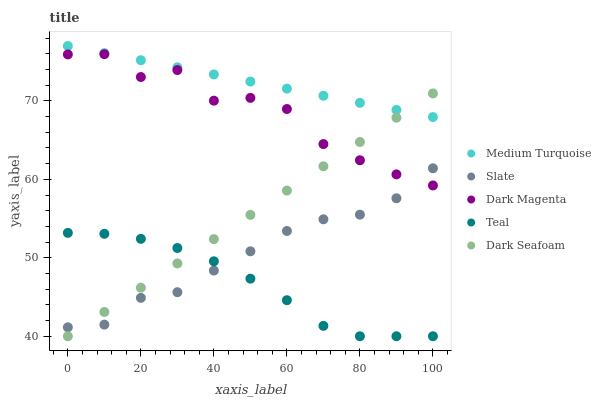Does Teal have the minimum area under the curve?
Answer yes or no. Yes. Does Medium Turquoise have the maximum area under the curve?
Answer yes or no. Yes. Does Slate have the minimum area under the curve?
Answer yes or no. No. Does Slate have the maximum area under the curve?
Answer yes or no. No. Is Medium Turquoise the smoothest?
Answer yes or no. Yes. Is Dark Magenta the roughest?
Answer yes or no. Yes. Is Slate the smoothest?
Answer yes or no. No. Is Slate the roughest?
Answer yes or no. No. Does Teal have the lowest value?
Answer yes or no. Yes. Does Slate have the lowest value?
Answer yes or no. No. Does Medium Turquoise have the highest value?
Answer yes or no. Yes. Does Slate have the highest value?
Answer yes or no. No. Is Dark Magenta less than Medium Turquoise?
Answer yes or no. Yes. Is Medium Turquoise greater than Dark Magenta?
Answer yes or no. Yes. Does Dark Seafoam intersect Medium Turquoise?
Answer yes or no. Yes. Is Dark Seafoam less than Medium Turquoise?
Answer yes or no. No. Is Dark Seafoam greater than Medium Turquoise?
Answer yes or no. No. Does Dark Magenta intersect Medium Turquoise?
Answer yes or no. No. 